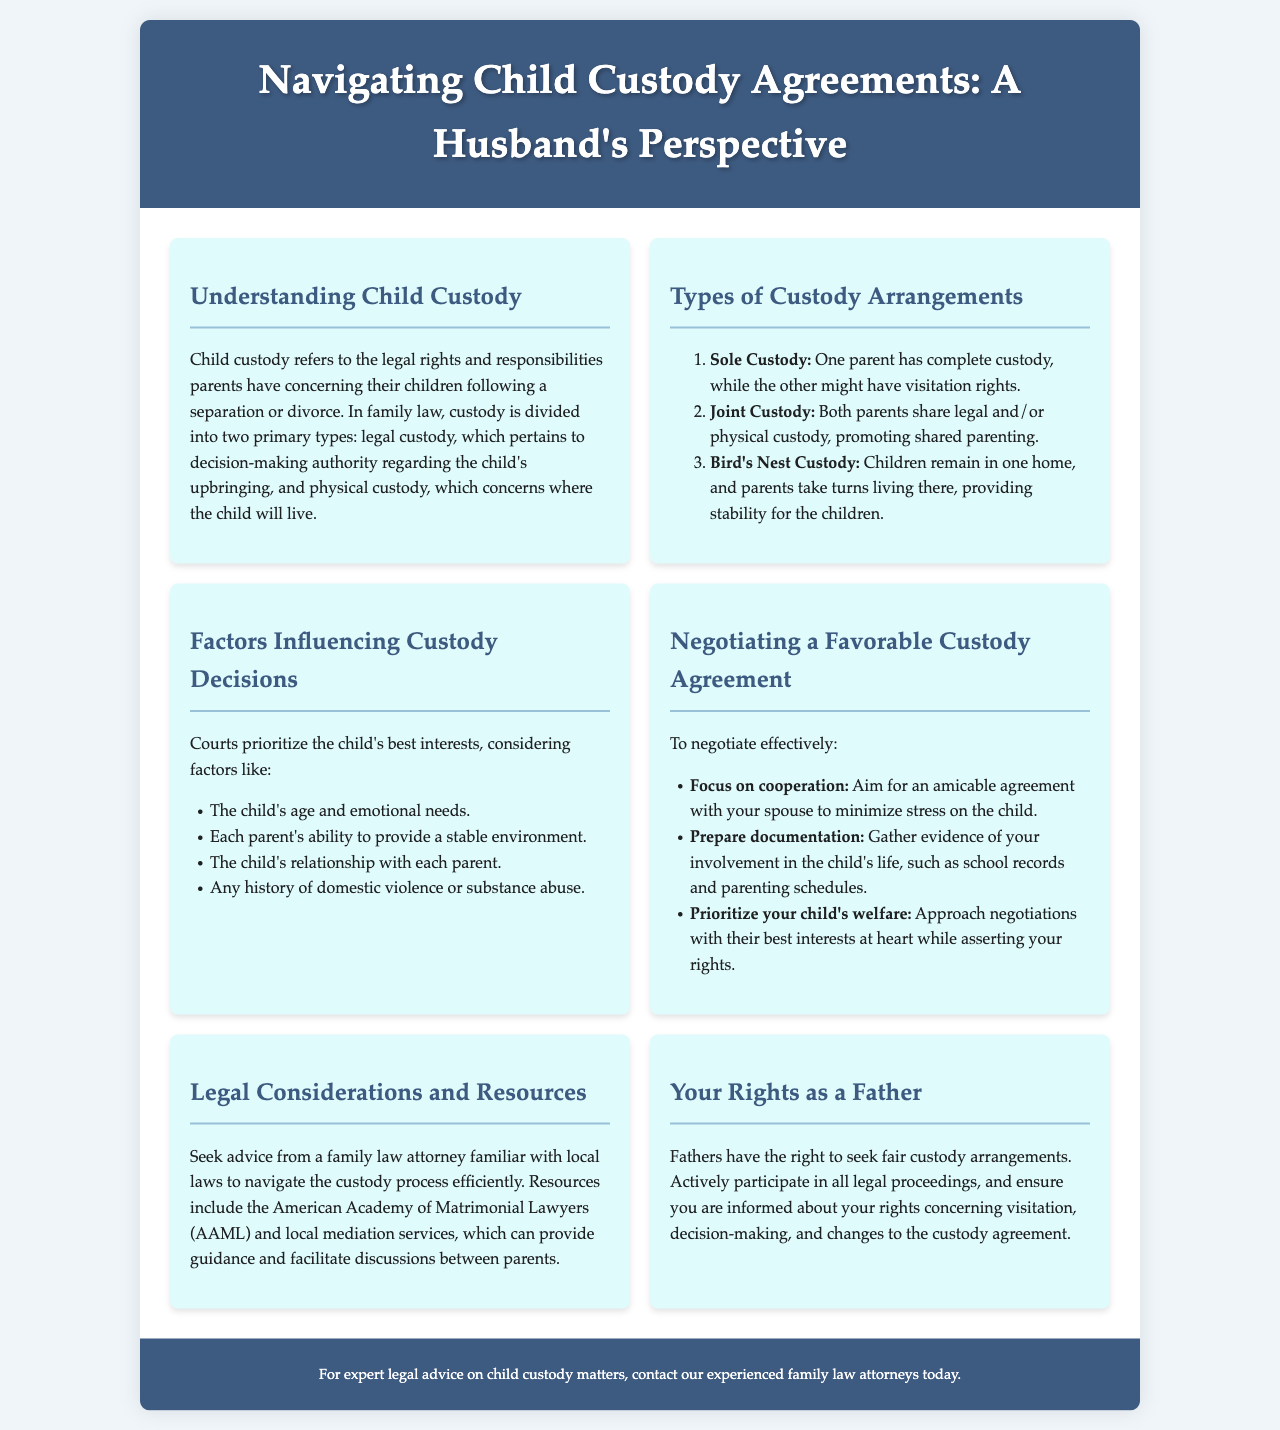What is the title of the brochure? The title is prominently displayed at the top of the brochure, indicating the main topic covered.
Answer: Navigating Child Custody Agreements: A Husband's Perspective What are the two primary types of custody? The document explicitly states the main categories under child custody, specifying the division of custody types.
Answer: Legal custody and physical custody What is sole custody? This term is defined as a specific custody arrangement illustrating the distribution of custody rights.
Answer: One parent has complete custody What factor is considered in custody decisions? The brochure lists multiple factors affecting custody decisions, requiring identification of one from the list.
Answer: The child's age and emotional needs What should be prioritized during negotiations? The brochure emphasizes an important aspect when entering custody negotiations by highlighting what should come first.
Answer: Your child's welfare Which organization can provide resources for custody matters? The document mentions a specific organization offering guidance and support pertinent to custody issues.
Answer: American Academy of Matrimonial Lawyers (AAML) How should documentation be prepared for negotiations? The brochure advises on the type of preparation needed, specifically concerning evidence gathering.
Answer: Gather evidence of your involvement in the child's life What type of custody promotes shared parenting? The document explicitly identifies the type of custody arrangement that allows both parents to share responsibilities.
Answer: Joint Custody What should fathers seek in custody arrangements? The brochure conveys a fundamental right fathers have concerning custody arrangements.
Answer: Fair custody arrangements 